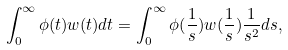<formula> <loc_0><loc_0><loc_500><loc_500>\int _ { 0 } ^ { \infty } \phi ( t ) w ( t ) d t = \int _ { 0 } ^ { \infty } \phi ( \frac { 1 } s ) w ( \frac { 1 } s ) \frac { 1 } { s ^ { 2 } } d s ,</formula> 